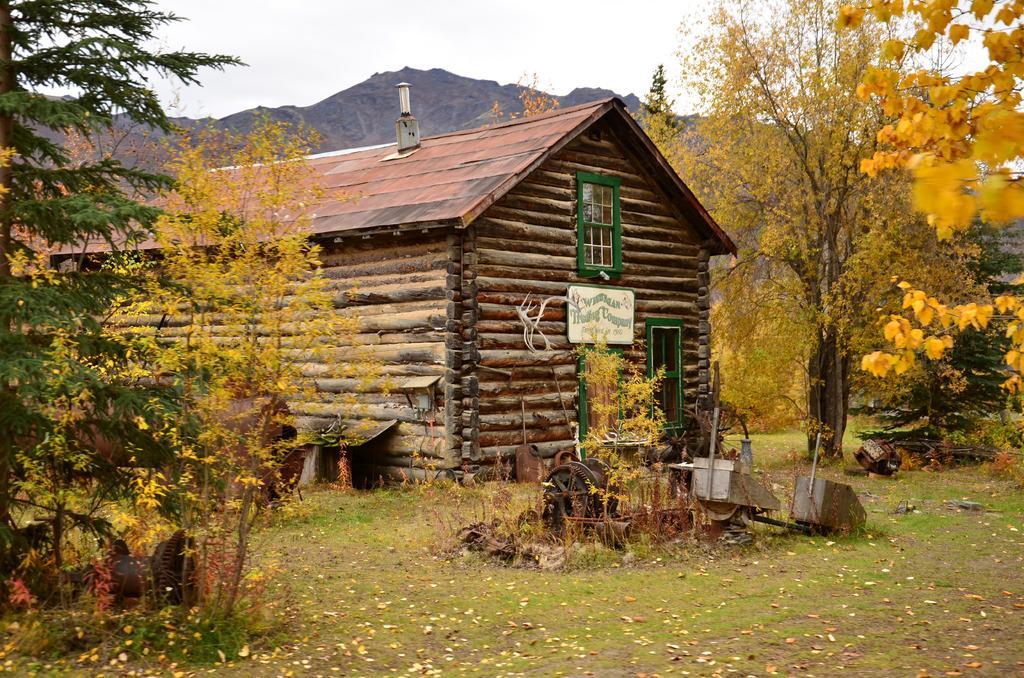Could you give a brief overview of what you see in this image? In the middle of the picture, we see a house and beside that, there is a machine. We even see a white board with some text written on it is placed on that house. On either side of the house, there are trees. At the bottom of the picture, we see grass and dried leaves. We see a hill in the background and at the top of the picture, we see the sky. 